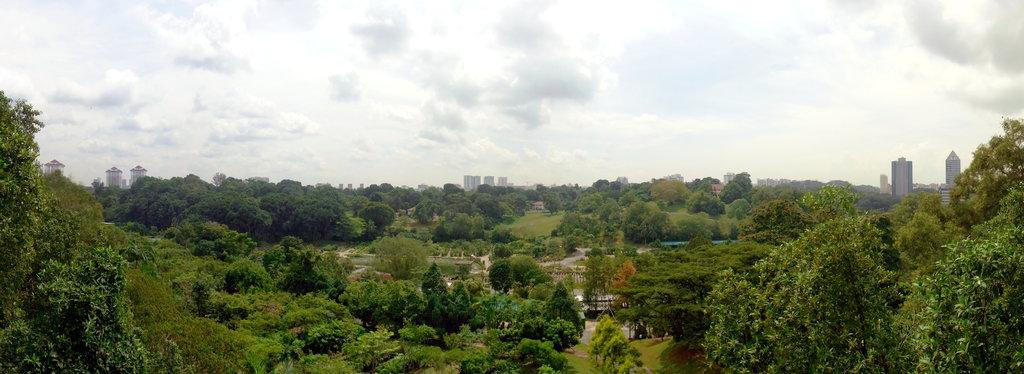What can be seen at the bottom of the image? There are trees, buildings, and a walkway at the bottom of the image. What is visible in the background of the image? There are trees and buildings in the background of the image. What is visible at the top of the image? The sky is visible at the top of the image. What type of tin can be seen in the hands of a person in the image? There are no people or tins present in the image. How many roses can be seen in the image? There are no roses present in the image. 